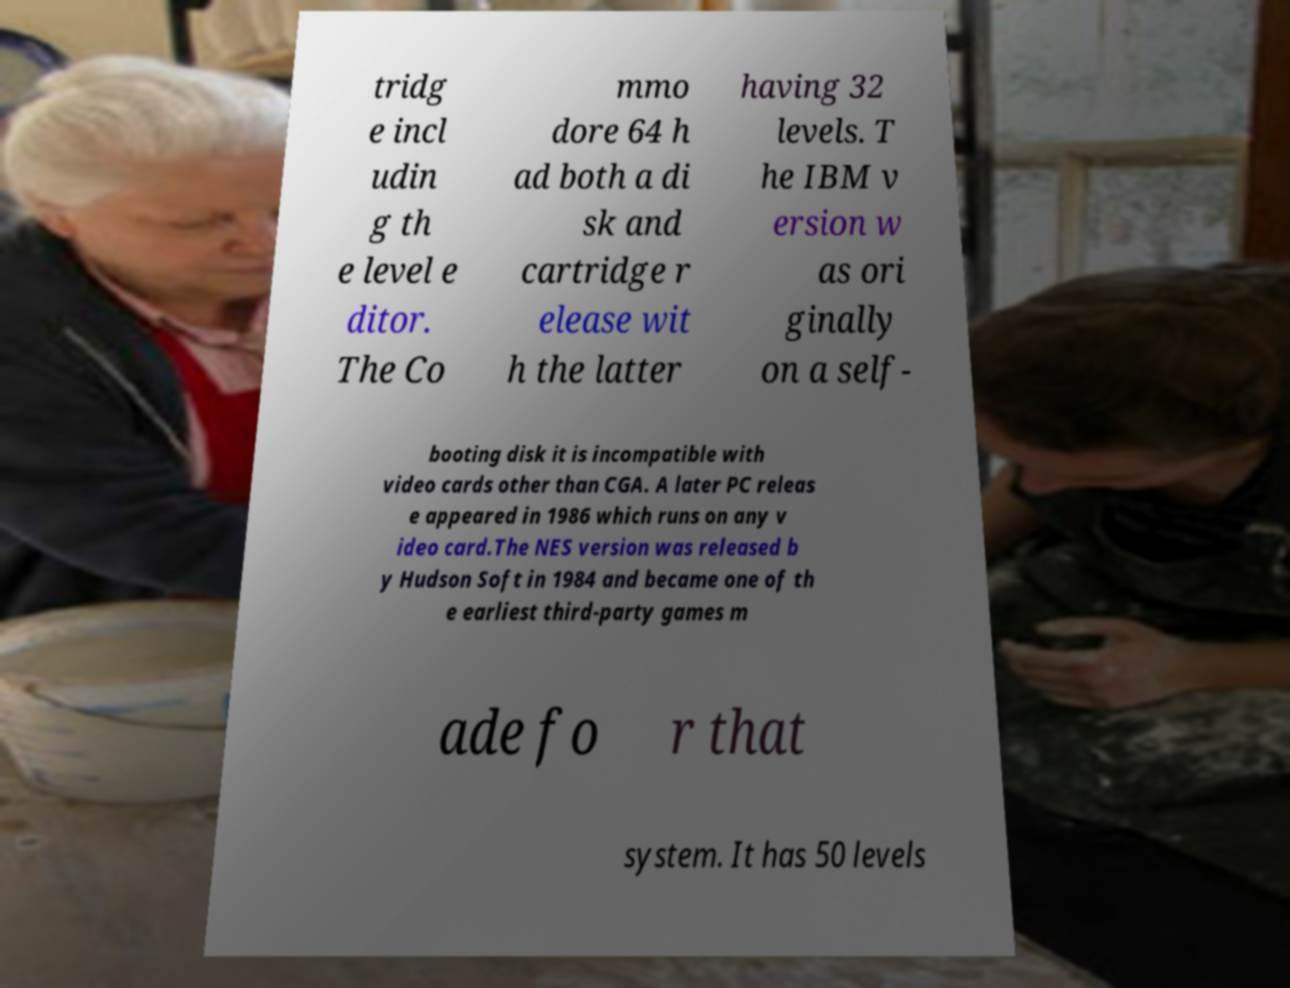Can you accurately transcribe the text from the provided image for me? tridg e incl udin g th e level e ditor. The Co mmo dore 64 h ad both a di sk and cartridge r elease wit h the latter having 32 levels. T he IBM v ersion w as ori ginally on a self- booting disk it is incompatible with video cards other than CGA. A later PC releas e appeared in 1986 which runs on any v ideo card.The NES version was released b y Hudson Soft in 1984 and became one of th e earliest third-party games m ade fo r that system. It has 50 levels 